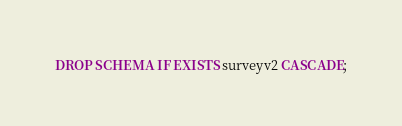Convert code to text. <code><loc_0><loc_0><loc_500><loc_500><_SQL_>DROP SCHEMA IF EXISTS surveyv2 CASCADE;</code> 